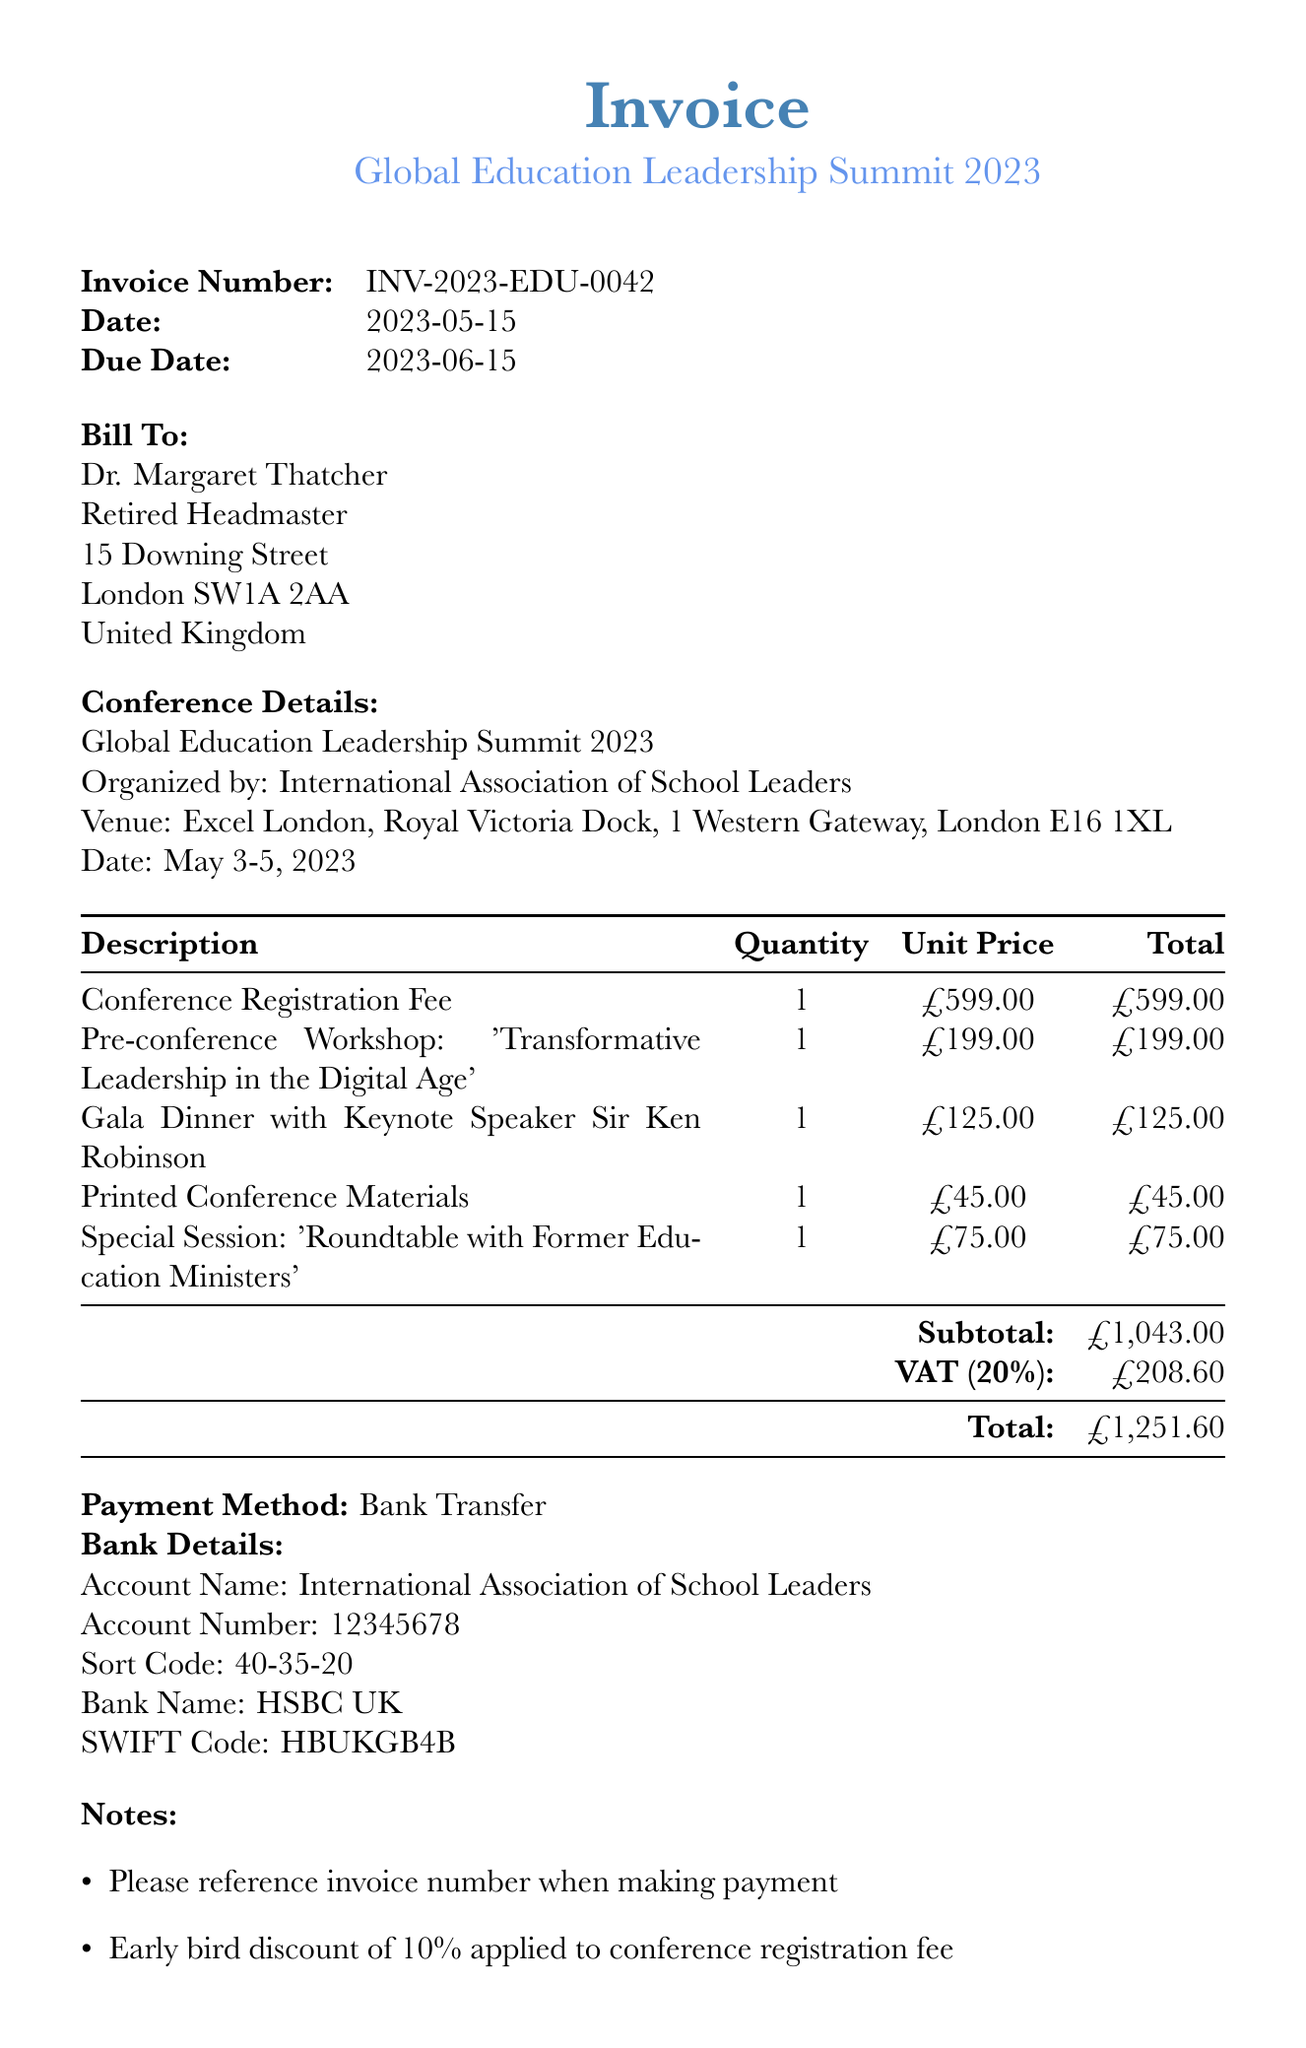What is the invoice number? The invoice number is provided at the top of the document, specifically labeled for easy identification.
Answer: INV-2023-EDU-0042 Who is the bill to? The bill to section specifies the individual the invoice is addressed to, including their title and location.
Answer: Dr. Margaret Thatcher What is the total amount due? The total amount due is listed at the bottom of the itemized expenses and includes all fees and VAT.
Answer: £1,251.60 What is the date range of the conference? The document includes details about the event, specifically mentioning when it takes place.
Answer: May 3-5, 2023 What is the subtotal before VAT? The subtotal is a separate calculation of costs before taxes and is clearly outlined in the expenses table.
Answer: £1,043.00 What payment method is specified? The payment method is indicated in the document to guide the recipient on how to process the payment.
Answer: Bank Transfer How much is the VAT charged? The VAT amount is detailed in the invoice under the tax section and is important for final calculations.
Answer: £208.60 What workshop is listed as a pre-conference event? The invoice includes a specific workshop available before the main conference activities.
Answer: Transformative Leadership in the Digital Age 